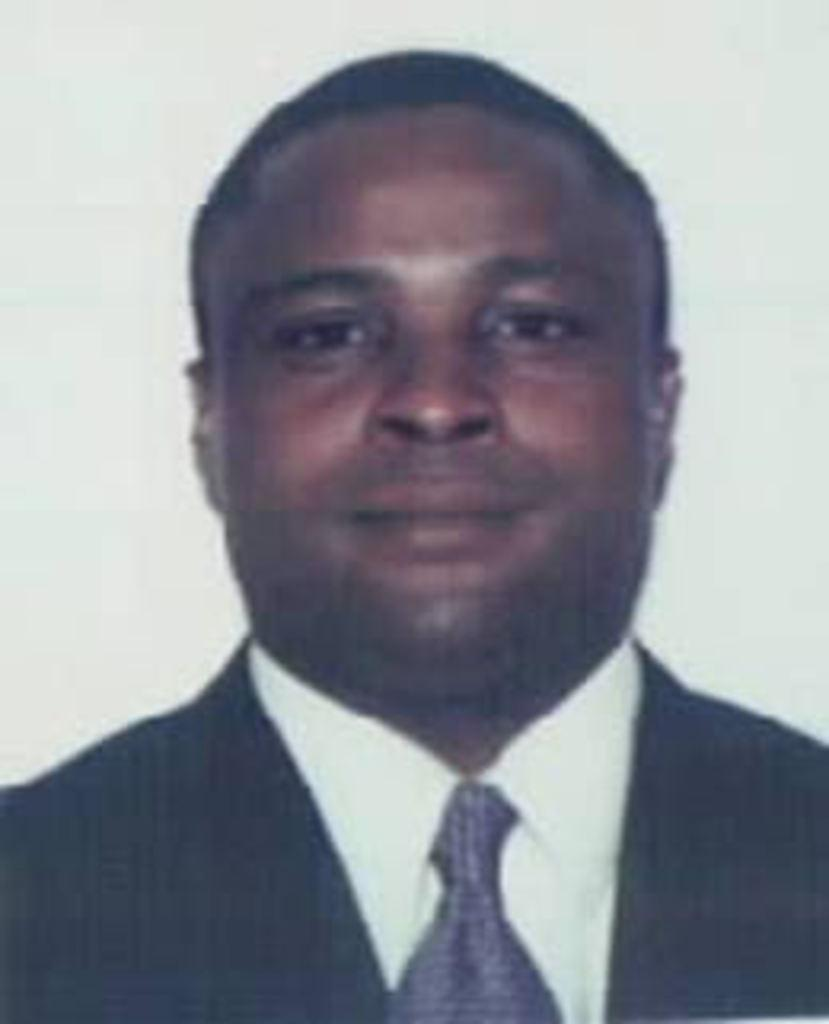Who or what is the main subject in the image? There is a person in the image. Can you describe the background of the image? The background of the image is blurred. What type of cracker is the person holding in the image? There is no cracker present in the image. What is the best way to reach the person in the image? The question is not relevant to the image, as it does not provide information about the person's location or accessibility. 